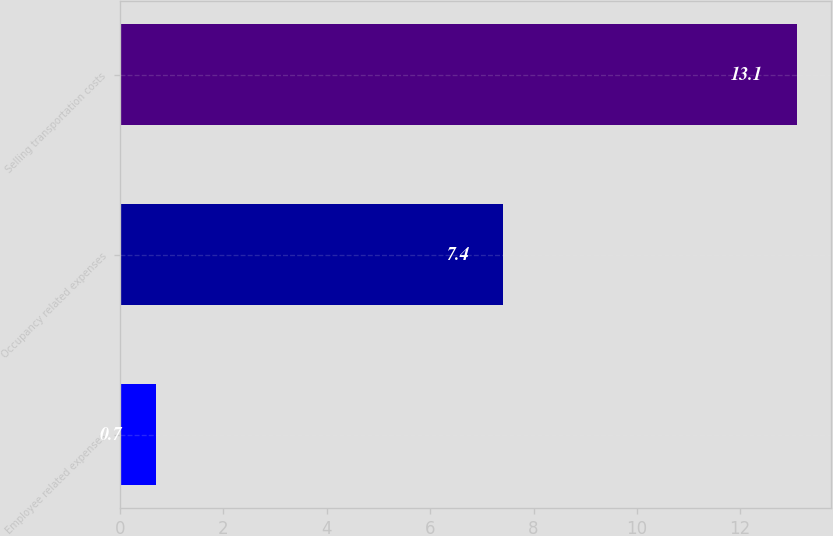Convert chart to OTSL. <chart><loc_0><loc_0><loc_500><loc_500><bar_chart><fcel>Employee related expenses<fcel>Occupancy related expenses<fcel>Selling transportation costs<nl><fcel>0.7<fcel>7.4<fcel>13.1<nl></chart> 